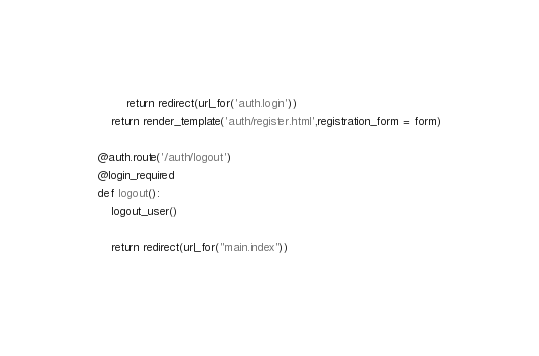<code> <loc_0><loc_0><loc_500><loc_500><_Python_>        return redirect(url_for('auth.login'))
    return render_template('auth/register.html',registration_form = form)

@auth.route('/auth/logout')
@login_required
def logout():
    logout_user()
    
    return redirect(url_for("main.index"))   </code> 